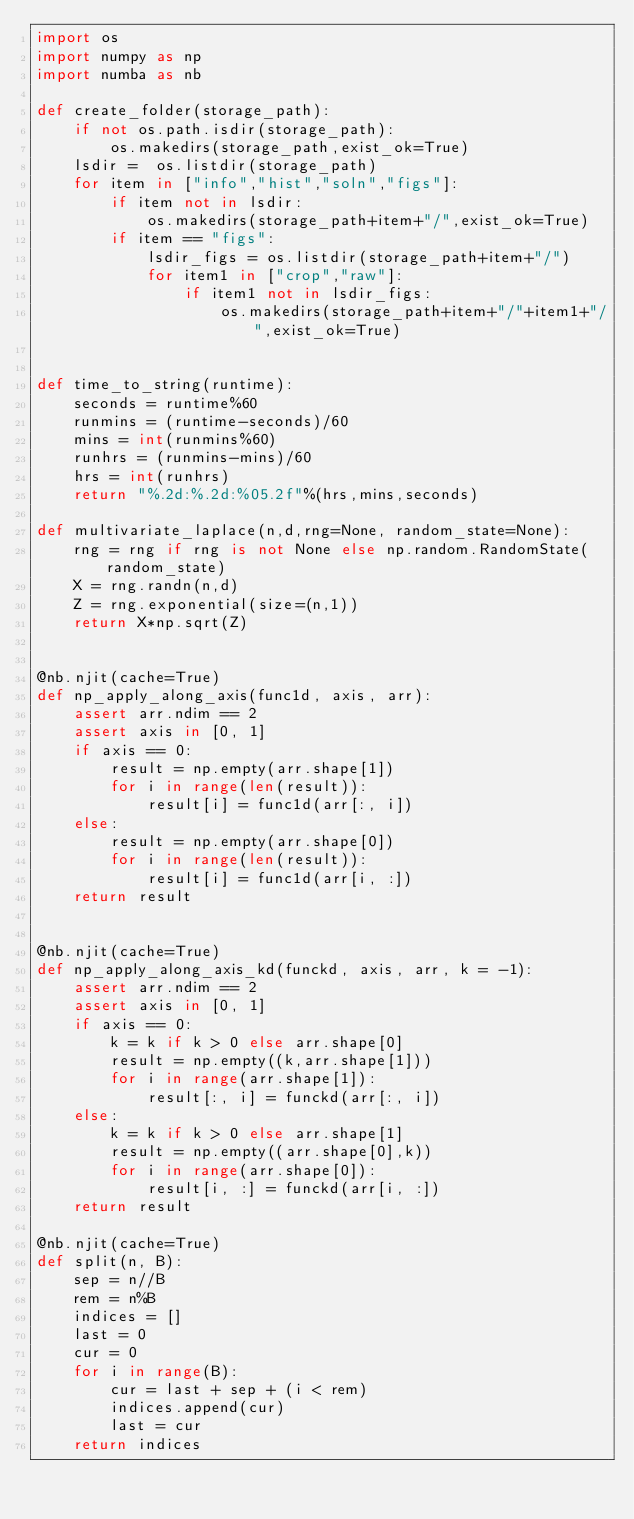Convert code to text. <code><loc_0><loc_0><loc_500><loc_500><_Python_>import os
import numpy as np
import numba as nb

def create_folder(storage_path):
    if not os.path.isdir(storage_path):
        os.makedirs(storage_path,exist_ok=True)
    lsdir =  os.listdir(storage_path)
    for item in ["info","hist","soln","figs"]:
        if item not in lsdir:
            os.makedirs(storage_path+item+"/",exist_ok=True)
        if item == "figs":
            lsdir_figs = os.listdir(storage_path+item+"/")
            for item1 in ["crop","raw"]:
                if item1 not in lsdir_figs:
                    os.makedirs(storage_path+item+"/"+item1+"/",exist_ok=True)
                    
                    
def time_to_string(runtime):
    seconds = runtime%60
    runmins = (runtime-seconds)/60
    mins = int(runmins%60)
    runhrs = (runmins-mins)/60
    hrs = int(runhrs)
    return "%.2d:%.2d:%05.2f"%(hrs,mins,seconds)

def multivariate_laplace(n,d,rng=None, random_state=None):
    rng = rng if rng is not None else np.random.RandomState(random_state)
    X = rng.randn(n,d)
    Z = rng.exponential(size=(n,1))
    return X*np.sqrt(Z)


@nb.njit(cache=True)
def np_apply_along_axis(func1d, axis, arr):
    assert arr.ndim == 2
    assert axis in [0, 1]
    if axis == 0:
        result = np.empty(arr.shape[1])
        for i in range(len(result)):
            result[i] = func1d(arr[:, i])
    else:
        result = np.empty(arr.shape[0])
        for i in range(len(result)):
            result[i] = func1d(arr[i, :])
    return result


@nb.njit(cache=True)
def np_apply_along_axis_kd(funckd, axis, arr, k = -1):
    assert arr.ndim == 2
    assert axis in [0, 1]
    if axis == 0:
        k = k if k > 0 else arr.shape[0]
        result = np.empty((k,arr.shape[1]))
        for i in range(arr.shape[1]):
            result[:, i] = funckd(arr[:, i])
    else:
        k = k if k > 0 else arr.shape[1]
        result = np.empty((arr.shape[0],k))
        for i in range(arr.shape[0]):
            result[i, :] = funckd(arr[i, :])
    return result

@nb.njit(cache=True)
def split(n, B):
    sep = n//B
    rem = n%B
    indices = []
    last = 0
    cur = 0
    for i in range(B):
        cur = last + sep + (i < rem)
        indices.append(cur)
        last = cur
    return indices

</code> 